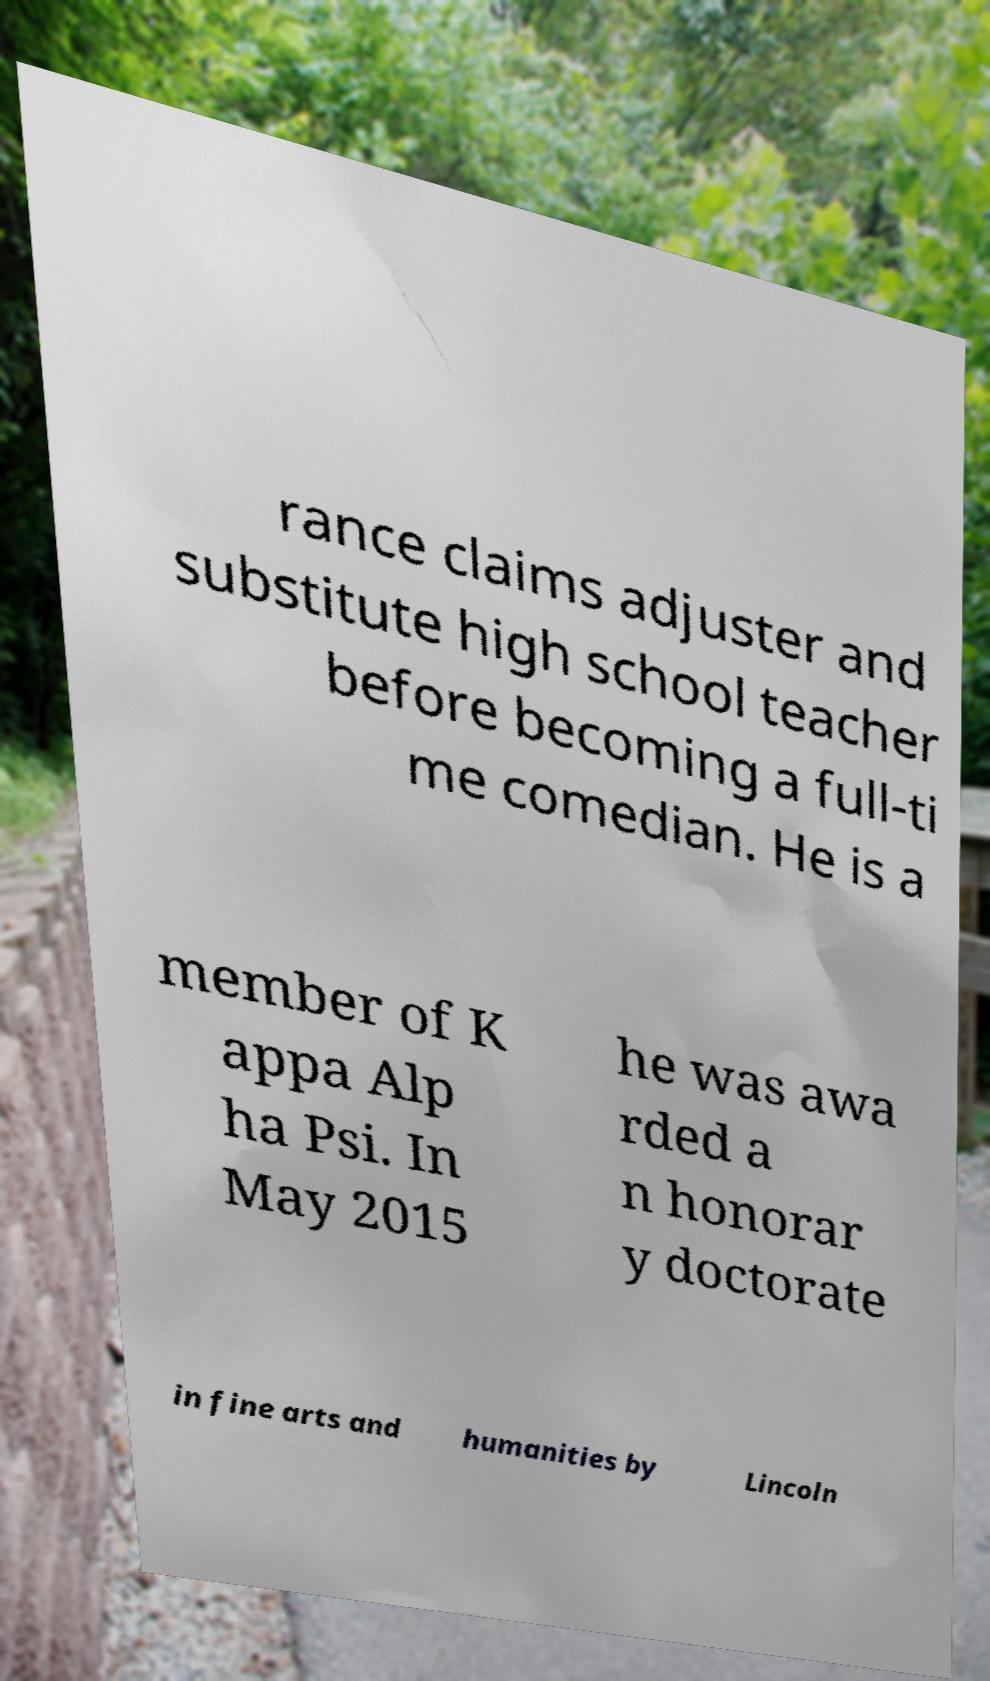What messages or text are displayed in this image? I need them in a readable, typed format. rance claims adjuster and substitute high school teacher before becoming a full-ti me comedian. He is a member of K appa Alp ha Psi. In May 2015 he was awa rded a n honorar y doctorate in fine arts and humanities by Lincoln 